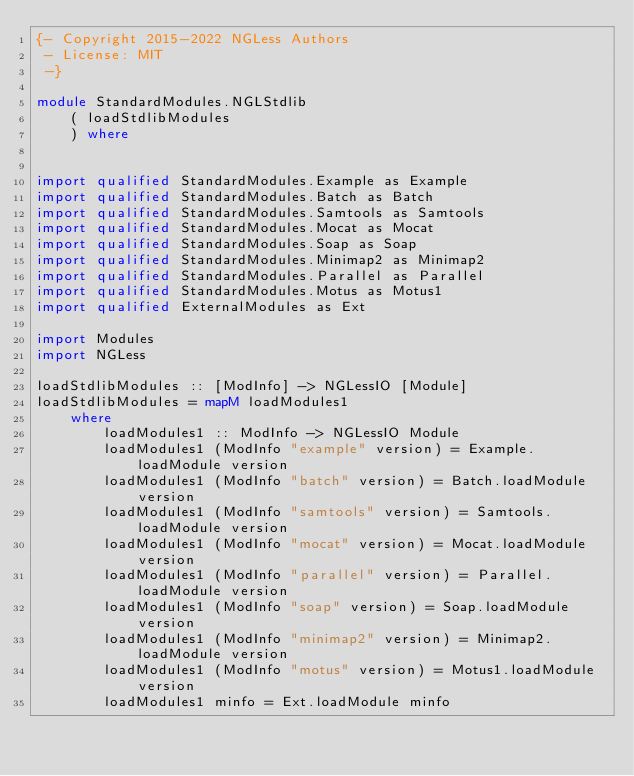<code> <loc_0><loc_0><loc_500><loc_500><_Haskell_>{- Copyright 2015-2022 NGLess Authors
 - License: MIT
 -}

module StandardModules.NGLStdlib
    ( loadStdlibModules
    ) where


import qualified StandardModules.Example as Example
import qualified StandardModules.Batch as Batch
import qualified StandardModules.Samtools as Samtools
import qualified StandardModules.Mocat as Mocat
import qualified StandardModules.Soap as Soap
import qualified StandardModules.Minimap2 as Minimap2
import qualified StandardModules.Parallel as Parallel
import qualified StandardModules.Motus as Motus1
import qualified ExternalModules as Ext

import Modules
import NGLess

loadStdlibModules :: [ModInfo] -> NGLessIO [Module]
loadStdlibModules = mapM loadModules1
    where
        loadModules1 :: ModInfo -> NGLessIO Module
        loadModules1 (ModInfo "example" version) = Example.loadModule version
        loadModules1 (ModInfo "batch" version) = Batch.loadModule version
        loadModules1 (ModInfo "samtools" version) = Samtools.loadModule version
        loadModules1 (ModInfo "mocat" version) = Mocat.loadModule version
        loadModules1 (ModInfo "parallel" version) = Parallel.loadModule version
        loadModules1 (ModInfo "soap" version) = Soap.loadModule version
        loadModules1 (ModInfo "minimap2" version) = Minimap2.loadModule version
        loadModules1 (ModInfo "motus" version) = Motus1.loadModule version
        loadModules1 minfo = Ext.loadModule minfo

</code> 